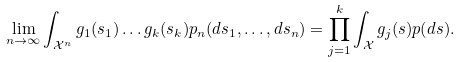Convert formula to latex. <formula><loc_0><loc_0><loc_500><loc_500>\lim _ { n \to \infty } \int _ { \mathcal { X } ^ { n } } g _ { 1 } ( s _ { 1 } ) \dots g _ { k } ( s _ { k } ) p _ { n } ( d s _ { 1 } , \dots , d s _ { n } ) = \prod _ { j = 1 } ^ { k } \int _ { \mathcal { X } } g _ { j } ( s ) p ( d s ) .</formula> 